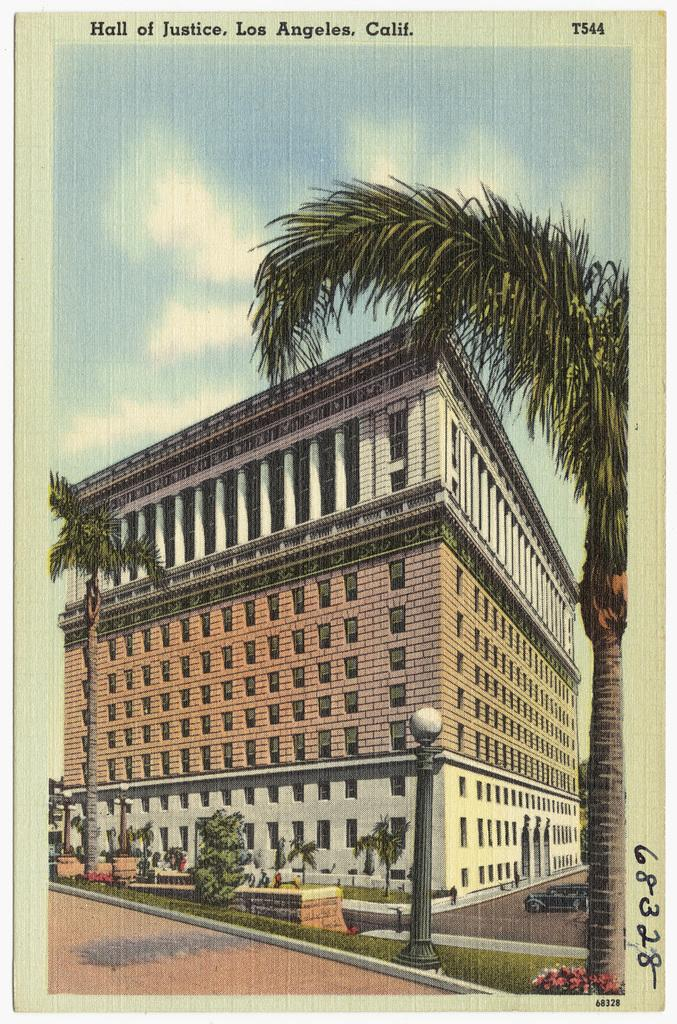What is located in the foreground of the image? There is a building, a street light pole, a path, and trees in the foreground of the image. What can be seen above the foreground elements in the image? The sky is visible in the image. Are there any visible weather conditions in the image? Yes, there are clouds visible in the sky. Can you tell me how many bees are buzzing around the street light pole in the image? There are no bees present in the image; the focus is on the building, street light pole, path, trees, sky, and clouds. Is there a cow grazing on the path in the image? There is no cow present in the image; the focus is on the building, street light pole, path, trees, sky, and clouds. 